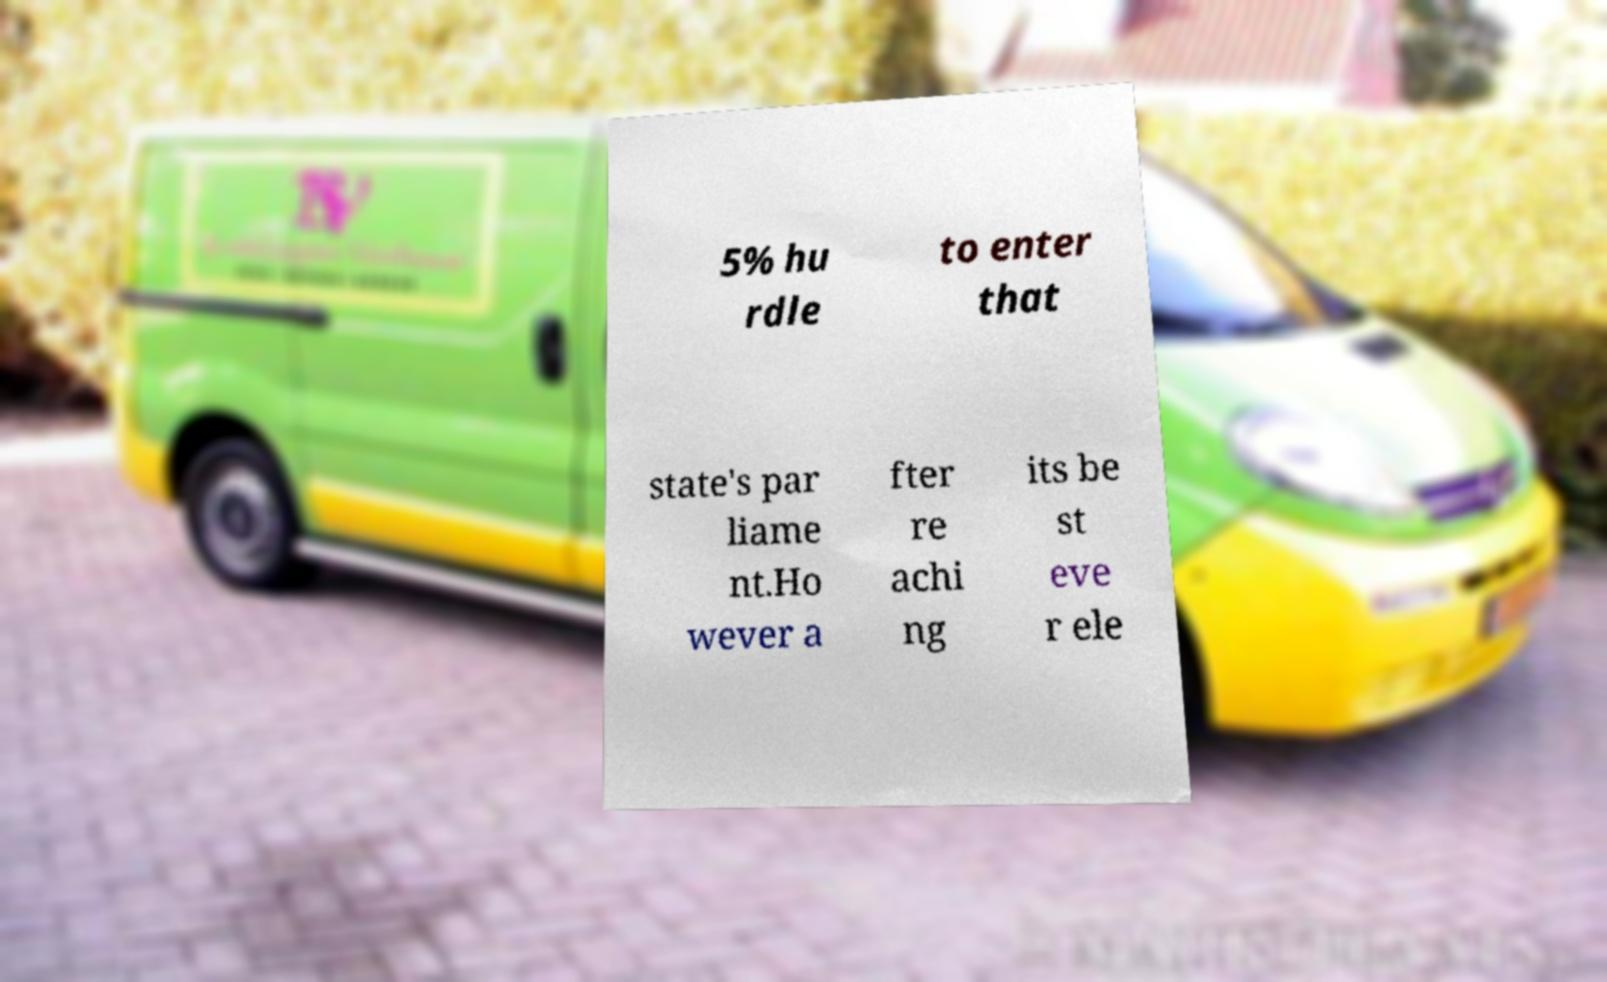Can you accurately transcribe the text from the provided image for me? 5% hu rdle to enter that state's par liame nt.Ho wever a fter re achi ng its be st eve r ele 